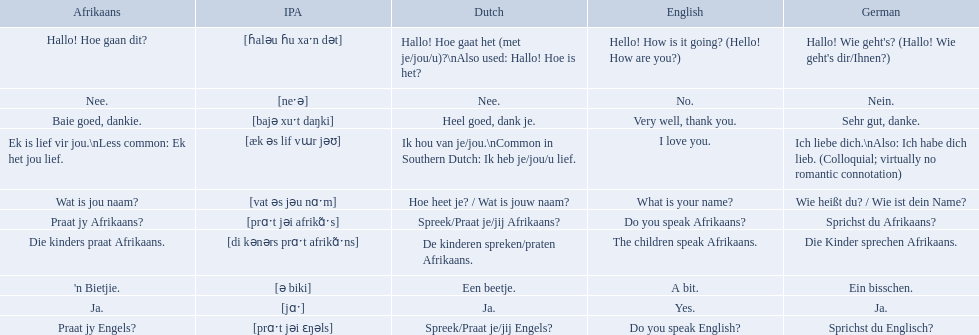What are the listed afrikaans phrases? Hallo! Hoe gaan dit?, Baie goed, dankie., Praat jy Afrikaans?, Praat jy Engels?, Ja., Nee., 'n Bietjie., Wat is jou naam?, Die kinders praat Afrikaans., Ek is lief vir jou.\nLess common: Ek het jou lief. Which is die kinders praat afrikaans? Die kinders praat Afrikaans. What is its german translation? Die Kinder sprechen Afrikaans. Which phrases are said in africaans? Hallo! Hoe gaan dit?, Baie goed, dankie., Praat jy Afrikaans?, Praat jy Engels?, Ja., Nee., 'n Bietjie., Wat is jou naam?, Die kinders praat Afrikaans., Ek is lief vir jou.\nLess common: Ek het jou lief. Which of these mean how do you speak afrikaans? Praat jy Afrikaans?. 